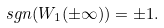Convert formula to latex. <formula><loc_0><loc_0><loc_500><loc_500>\ s g n ( W _ { 1 } ( \pm \infty ) ) = \pm 1 .</formula> 